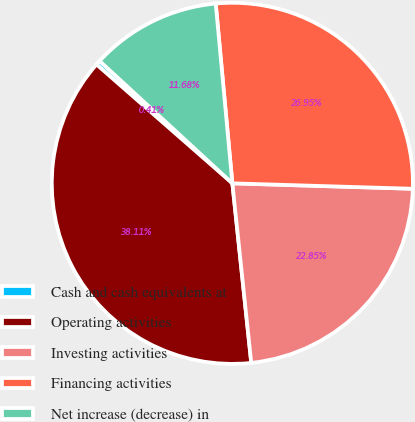<chart> <loc_0><loc_0><loc_500><loc_500><pie_chart><fcel>Cash and cash equivalents at<fcel>Operating activities<fcel>Investing activities<fcel>Financing activities<fcel>Net increase (decrease) in<nl><fcel>0.41%<fcel>38.11%<fcel>22.85%<fcel>26.95%<fcel>11.68%<nl></chart> 